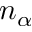Convert formula to latex. <formula><loc_0><loc_0><loc_500><loc_500>n _ { \alpha }</formula> 